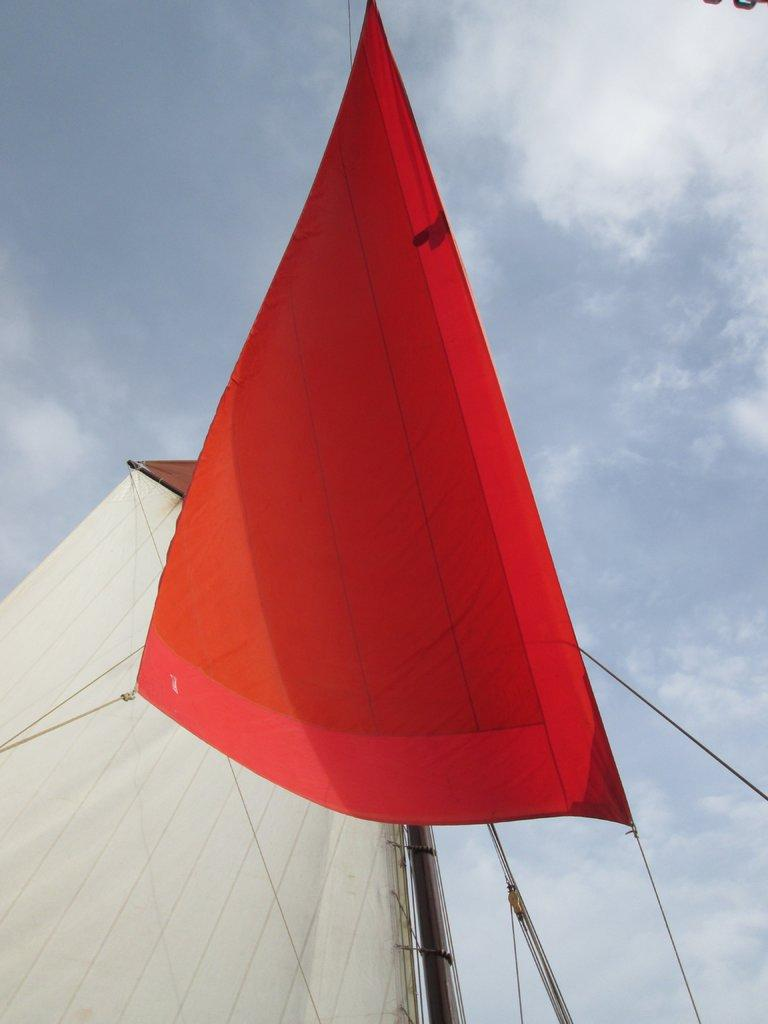What is the color of the mast on the left side of the image? The mast on the left side of the image is red. How is the red mast connected to other elements in the image? The red mast is attached to threads. What is the color of the mast on the right side of the image? The mast on the right side of the image is white. How is the white mast connected to other elements in the image? The white mast is attached to a pole. What can be seen in the sky in the background of the image? There are clouds in the sky in the background of the image. How many sisters are visible in the image? There are no sisters present in the image; it features two masts and clouds in the sky. What type of crowd can be seen gathering around the white mast in the image? There is no crowd present in the image; it only shows the white mast attached to a pole and the red mast attached to threads. 